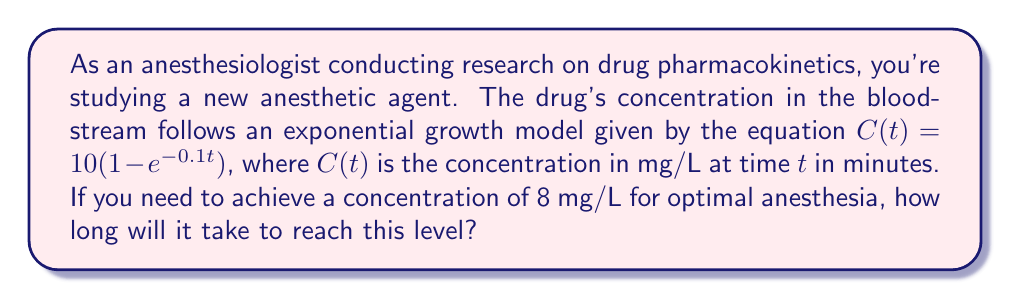Can you answer this question? To solve this problem, we'll use the given exponential growth equation and logarithms. Let's approach this step-by-step:

1) We start with the equation: $C(t) = 10(1 - e^{-0.1t})$

2) We want to find $t$ when $C(t) = 8$ mg/L. So, let's substitute this:

   $8 = 10(1 - e^{-0.1t})$

3) Divide both sides by 10:

   $0.8 = 1 - e^{-0.1t}$

4) Subtract both sides from 1:

   $0.2 = e^{-0.1t}$

5) Now, we can take the natural logarithm of both sides:

   $\ln(0.2) = \ln(e^{-0.1t})$

6) The natural log and exponential cancel on the right side:

   $\ln(0.2) = -0.1t$

7) Divide both sides by -0.1:

   $\frac{\ln(0.2)}{-0.1} = t$

8) Calculate the result:

   $t = -\frac{\ln(0.2)}{0.1} \approx 16.1$ minutes

Therefore, it will take approximately 16.1 minutes for the drug concentration to reach 8 mg/L.
Answer: $t \approx 16.1$ minutes 